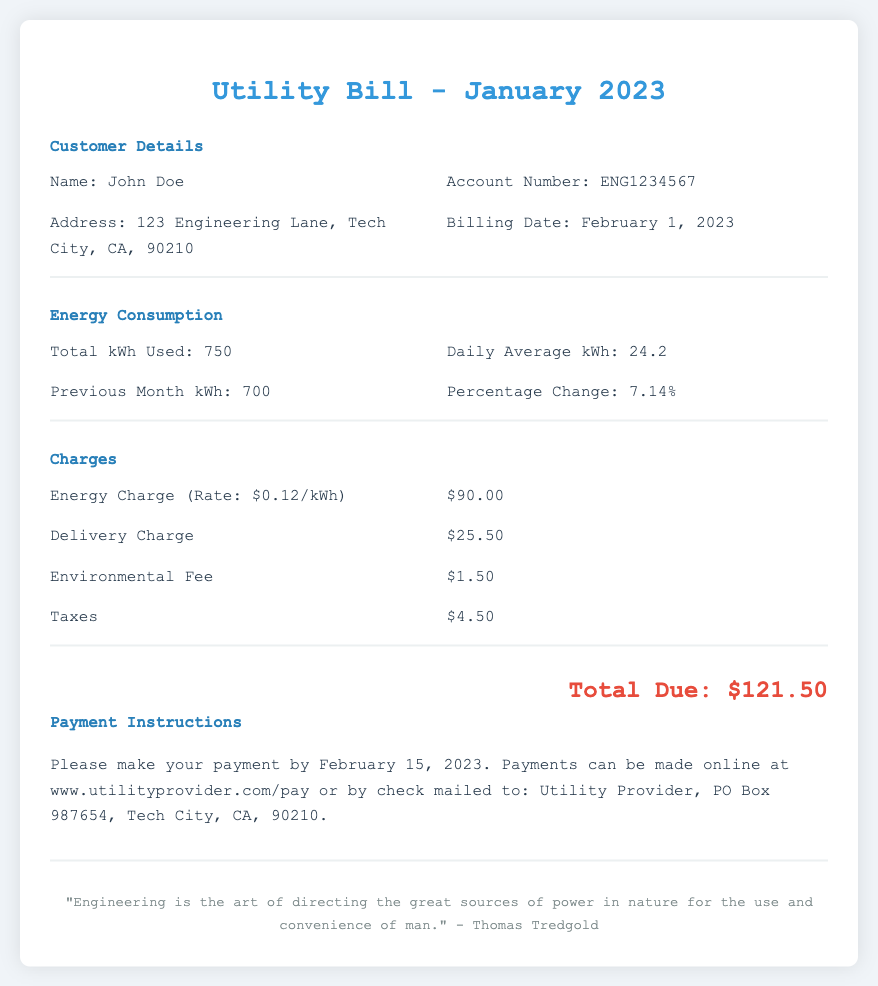What is the name of the customer? The name of the customer is provided in the document under Customer Details as "John Doe."
Answer: John Doe What is the total energy consumption in kWh? The total energy consumption is clearly stated in the Energy Consumption section of the document as "750 kWh."
Answer: 750 kWh What is the delivery charge? The delivery charge is mentioned in the Charges section as a standalone item with the corresponding amount.
Answer: $25.50 By what percentage did energy consumption change from the previous month? The percentage change is calculated and stated in the Energy Consumption section, showing the increase from the previous month.
Answer: 7.14% When is the payment due? The payment due date is specified in the Payment Instructions section as February 15, 2023.
Answer: February 15, 2023 What is the total amount due? The total amount due is prominently displayed at the bottom of the document after all charges are listed.
Answer: $121.50 What was the previous month’s energy usage? The previous month’s energy usage is directly stated in the Energy Consumption section for comparison.
Answer: 700 kWh What is the environmental fee? The environmental fee is included in the Charges section with its specific value listed.
Answer: $1.50 What average kWh was consumed daily? The document averages the daily kWh usage as stated in the Energy Consumption section.
Answer: 24.2 